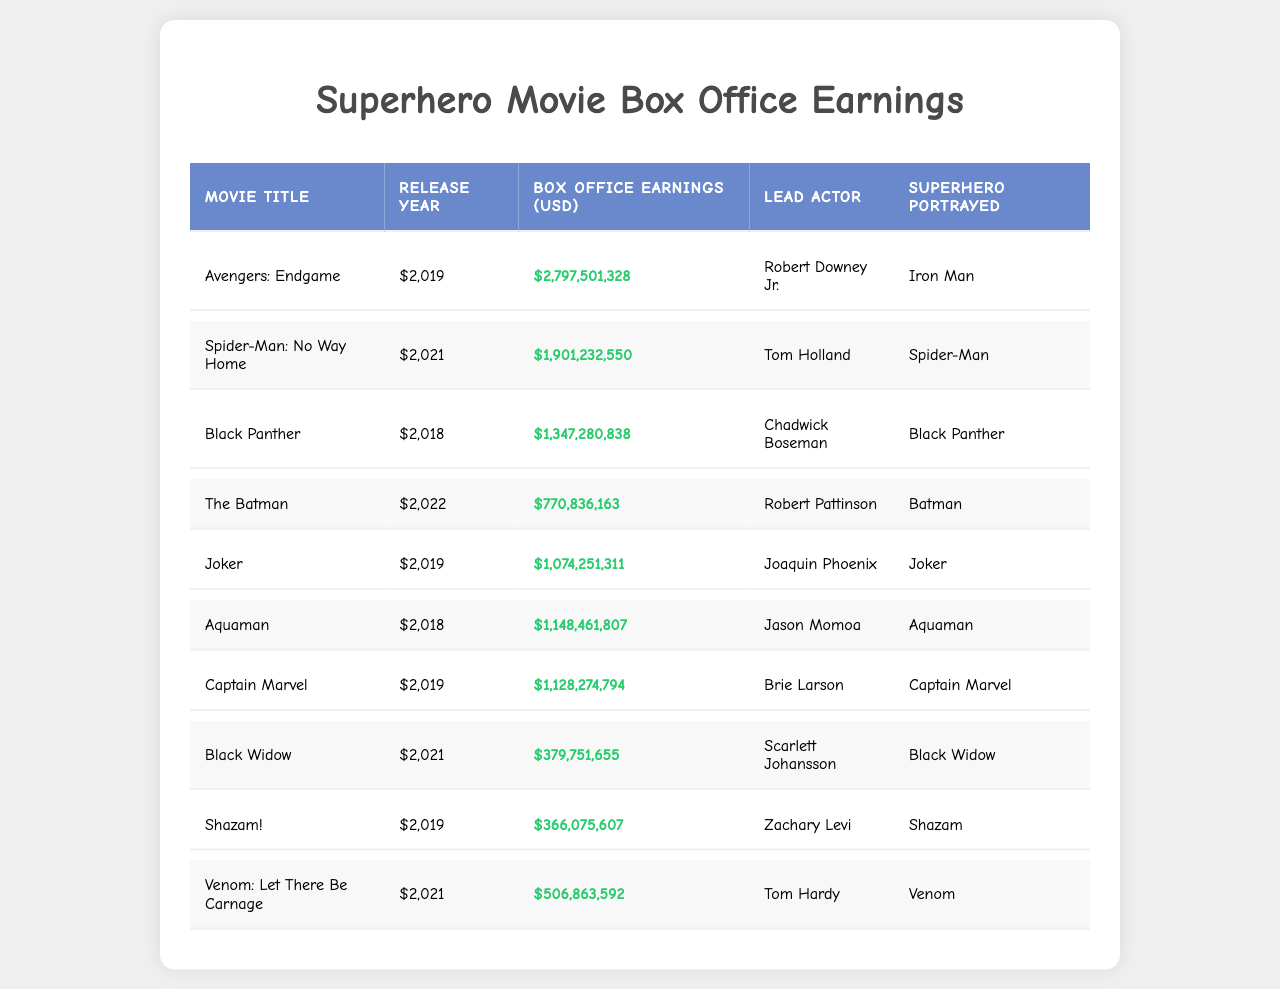What is the highest box office earning among these superhero movies? The highest box office earning can be identified by looking for the largest value in the "Box Office Earnings (USD)" column. The movie "Avengers: Endgame" has the highest earning of $2,797,501,328.
Answer: $2,797,501,328 Which superhero was portrayed by Tom Holland? Tom Holland is listed in the "Lead Actor" column for the movie "Spider-Man: No Way Home," which shows that he portrayed the superhero Spider-Man.
Answer: Spider-Man How many superhero movies were released in 2021? By scanning through the "Release Year" column, we can see that there are two movies listed for the year 2021: "Spider-Man: No Way Home" and "Black Widow." Therefore, there are two movies released in that year.
Answer: 2 What is the average box office earning of movies released in 2019? The earnings for the movies released in 2019 are $2,797,501,328 for "Avengers: Endgame," $1,074,251,311 for "Joker," and $1,128,274,794 for "Captain Marvel." Their sum is $5,000,027,433, and there are three movies, so the average is $5,000,027,433 / 3 = $1,666,675,811.
Answer: $1,666,675,811 Did "Aquaman" earn more than "Black Panther"? "Aquaman" has earnings of $1,148,461,807, while "Black Panther" earned $1,347,280,838. Since $1,148,461,807 is less than $1,347,280,838, "Aquaman" did not earn more than "Black Panther."
Answer: No Which movie had the lowest box office earnings? By reviewing the "Box Office Earnings (USD)" column and identifying the smallest value, we find "Black Widow" with earnings of $379,751,655.
Answer: $379,751,655 What is the total box office earning of all movies featuring a Batman character? The movies featuring Batman are "The Batman," which earned $770,836,163, and "Joker," which earned $1,074,251,311. Adding these together gives $770,836,163 + $1,074,251,311 = $1,845,087,474.
Answer: $1,845,087,474 Who is the lead actor in "Venom: Let There Be Carnage"? According to the "Lead Actor" column, the lead actor in "Venom: Let There Be Carnage" is Tom Hardy.
Answer: Tom Hardy What percentage of box office earnings do "Avengers: Endgame" represent among the listed movies? The total box office earnings for all listed movies is $10,071,919,017. "Avengers: Endgame" earned $2,797,501,328, which is calculated as ($2,797,501,328 / $10,071,919,017) * 100 ≈ 27.8%.
Answer: 27.8% What superhero has the highest box office earnings among the movies listed? Looking at the box office earnings, "Iron Man" related to "Avengers: Endgame" has the highest earnings of $2,797,501,328.
Answer: Iron Man 